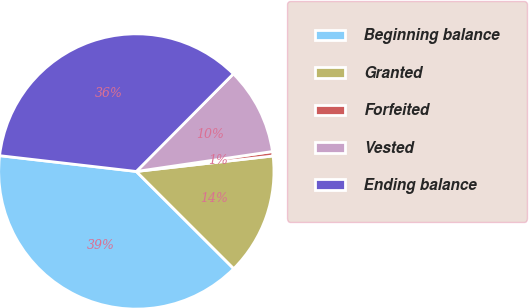Convert chart. <chart><loc_0><loc_0><loc_500><loc_500><pie_chart><fcel>Beginning balance<fcel>Granted<fcel>Forfeited<fcel>Vested<fcel>Ending balance<nl><fcel>39.35%<fcel>14.28%<fcel>0.52%<fcel>10.23%<fcel>35.62%<nl></chart> 